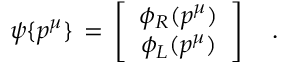<formula> <loc_0><loc_0><loc_500><loc_500>\psi \{ p ^ { \mu } \} \, = \, \left [ \begin{array} { c } { { \phi _ { R } ( p ^ { \mu } ) } } \\ { { \phi _ { L } ( p ^ { \mu } ) } } \end{array} \right ] \quad .</formula> 